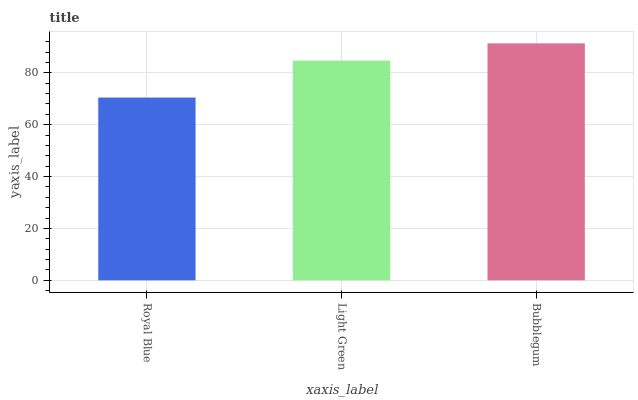Is Royal Blue the minimum?
Answer yes or no. Yes. Is Bubblegum the maximum?
Answer yes or no. Yes. Is Light Green the minimum?
Answer yes or no. No. Is Light Green the maximum?
Answer yes or no. No. Is Light Green greater than Royal Blue?
Answer yes or no. Yes. Is Royal Blue less than Light Green?
Answer yes or no. Yes. Is Royal Blue greater than Light Green?
Answer yes or no. No. Is Light Green less than Royal Blue?
Answer yes or no. No. Is Light Green the high median?
Answer yes or no. Yes. Is Light Green the low median?
Answer yes or no. Yes. Is Bubblegum the high median?
Answer yes or no. No. Is Royal Blue the low median?
Answer yes or no. No. 